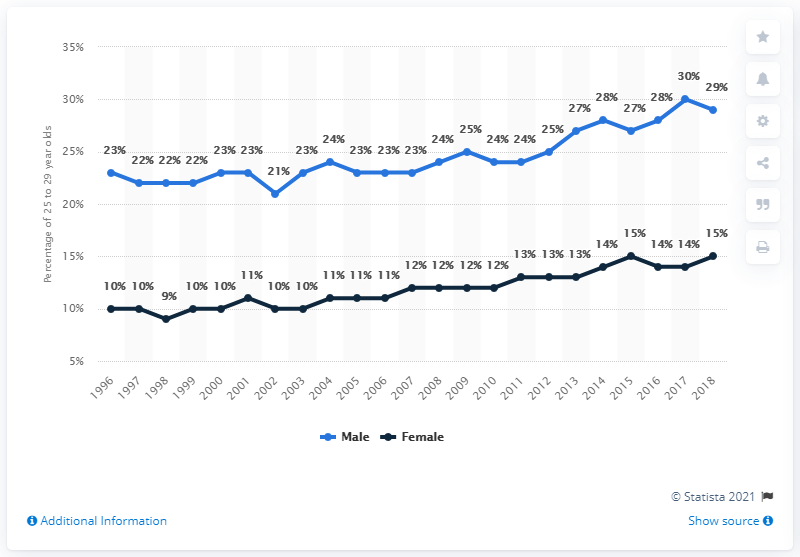Give some essential details in this illustration. The difference between the highest and lowest values in a black line chart is six. The lowest percentage value in the blue line chart is 21%. 